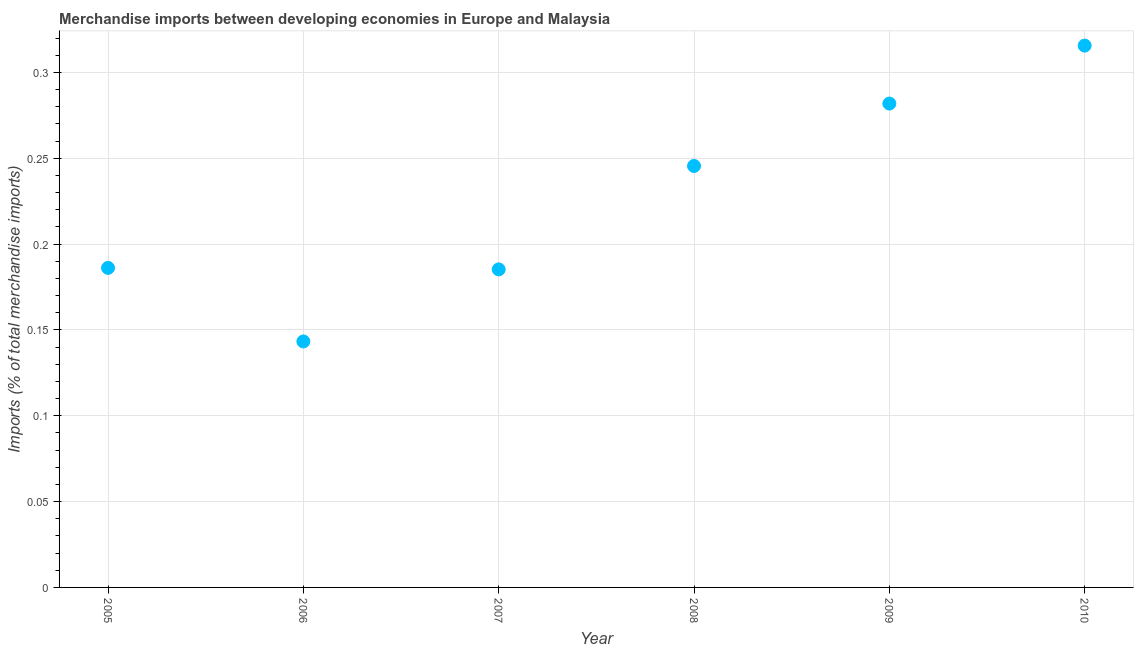What is the merchandise imports in 2005?
Your response must be concise. 0.19. Across all years, what is the maximum merchandise imports?
Make the answer very short. 0.32. Across all years, what is the minimum merchandise imports?
Offer a very short reply. 0.14. In which year was the merchandise imports maximum?
Provide a short and direct response. 2010. What is the sum of the merchandise imports?
Give a very brief answer. 1.36. What is the difference between the merchandise imports in 2005 and 2008?
Provide a succinct answer. -0.06. What is the average merchandise imports per year?
Offer a terse response. 0.23. What is the median merchandise imports?
Provide a short and direct response. 0.22. In how many years, is the merchandise imports greater than 0.08 %?
Provide a short and direct response. 6. Do a majority of the years between 2009 and 2010 (inclusive) have merchandise imports greater than 0.18000000000000002 %?
Offer a terse response. Yes. What is the ratio of the merchandise imports in 2005 to that in 2006?
Offer a very short reply. 1.3. Is the difference between the merchandise imports in 2007 and 2009 greater than the difference between any two years?
Your answer should be very brief. No. What is the difference between the highest and the second highest merchandise imports?
Give a very brief answer. 0.03. Is the sum of the merchandise imports in 2006 and 2008 greater than the maximum merchandise imports across all years?
Keep it short and to the point. Yes. What is the difference between the highest and the lowest merchandise imports?
Provide a short and direct response. 0.17. How many dotlines are there?
Provide a short and direct response. 1. How many years are there in the graph?
Offer a very short reply. 6. What is the difference between two consecutive major ticks on the Y-axis?
Your response must be concise. 0.05. Does the graph contain grids?
Your answer should be compact. Yes. What is the title of the graph?
Ensure brevity in your answer.  Merchandise imports between developing economies in Europe and Malaysia. What is the label or title of the Y-axis?
Your answer should be very brief. Imports (% of total merchandise imports). What is the Imports (% of total merchandise imports) in 2005?
Keep it short and to the point. 0.19. What is the Imports (% of total merchandise imports) in 2006?
Offer a very short reply. 0.14. What is the Imports (% of total merchandise imports) in 2007?
Your answer should be very brief. 0.19. What is the Imports (% of total merchandise imports) in 2008?
Keep it short and to the point. 0.25. What is the Imports (% of total merchandise imports) in 2009?
Offer a very short reply. 0.28. What is the Imports (% of total merchandise imports) in 2010?
Provide a short and direct response. 0.32. What is the difference between the Imports (% of total merchandise imports) in 2005 and 2006?
Make the answer very short. 0.04. What is the difference between the Imports (% of total merchandise imports) in 2005 and 2007?
Keep it short and to the point. 0. What is the difference between the Imports (% of total merchandise imports) in 2005 and 2008?
Provide a short and direct response. -0.06. What is the difference between the Imports (% of total merchandise imports) in 2005 and 2009?
Your response must be concise. -0.1. What is the difference between the Imports (% of total merchandise imports) in 2005 and 2010?
Offer a terse response. -0.13. What is the difference between the Imports (% of total merchandise imports) in 2006 and 2007?
Your response must be concise. -0.04. What is the difference between the Imports (% of total merchandise imports) in 2006 and 2008?
Give a very brief answer. -0.1. What is the difference between the Imports (% of total merchandise imports) in 2006 and 2009?
Ensure brevity in your answer.  -0.14. What is the difference between the Imports (% of total merchandise imports) in 2006 and 2010?
Keep it short and to the point. -0.17. What is the difference between the Imports (% of total merchandise imports) in 2007 and 2008?
Make the answer very short. -0.06. What is the difference between the Imports (% of total merchandise imports) in 2007 and 2009?
Your answer should be compact. -0.1. What is the difference between the Imports (% of total merchandise imports) in 2007 and 2010?
Your answer should be compact. -0.13. What is the difference between the Imports (% of total merchandise imports) in 2008 and 2009?
Give a very brief answer. -0.04. What is the difference between the Imports (% of total merchandise imports) in 2008 and 2010?
Your response must be concise. -0.07. What is the difference between the Imports (% of total merchandise imports) in 2009 and 2010?
Your answer should be very brief. -0.03. What is the ratio of the Imports (% of total merchandise imports) in 2005 to that in 2006?
Ensure brevity in your answer.  1.3. What is the ratio of the Imports (% of total merchandise imports) in 2005 to that in 2007?
Provide a succinct answer. 1. What is the ratio of the Imports (% of total merchandise imports) in 2005 to that in 2008?
Provide a short and direct response. 0.76. What is the ratio of the Imports (% of total merchandise imports) in 2005 to that in 2009?
Your answer should be very brief. 0.66. What is the ratio of the Imports (% of total merchandise imports) in 2005 to that in 2010?
Provide a short and direct response. 0.59. What is the ratio of the Imports (% of total merchandise imports) in 2006 to that in 2007?
Offer a very short reply. 0.77. What is the ratio of the Imports (% of total merchandise imports) in 2006 to that in 2008?
Provide a short and direct response. 0.58. What is the ratio of the Imports (% of total merchandise imports) in 2006 to that in 2009?
Your answer should be very brief. 0.51. What is the ratio of the Imports (% of total merchandise imports) in 2006 to that in 2010?
Provide a short and direct response. 0.45. What is the ratio of the Imports (% of total merchandise imports) in 2007 to that in 2008?
Ensure brevity in your answer.  0.76. What is the ratio of the Imports (% of total merchandise imports) in 2007 to that in 2009?
Offer a terse response. 0.66. What is the ratio of the Imports (% of total merchandise imports) in 2007 to that in 2010?
Provide a succinct answer. 0.59. What is the ratio of the Imports (% of total merchandise imports) in 2008 to that in 2009?
Your answer should be very brief. 0.87. What is the ratio of the Imports (% of total merchandise imports) in 2008 to that in 2010?
Your answer should be very brief. 0.78. What is the ratio of the Imports (% of total merchandise imports) in 2009 to that in 2010?
Make the answer very short. 0.89. 